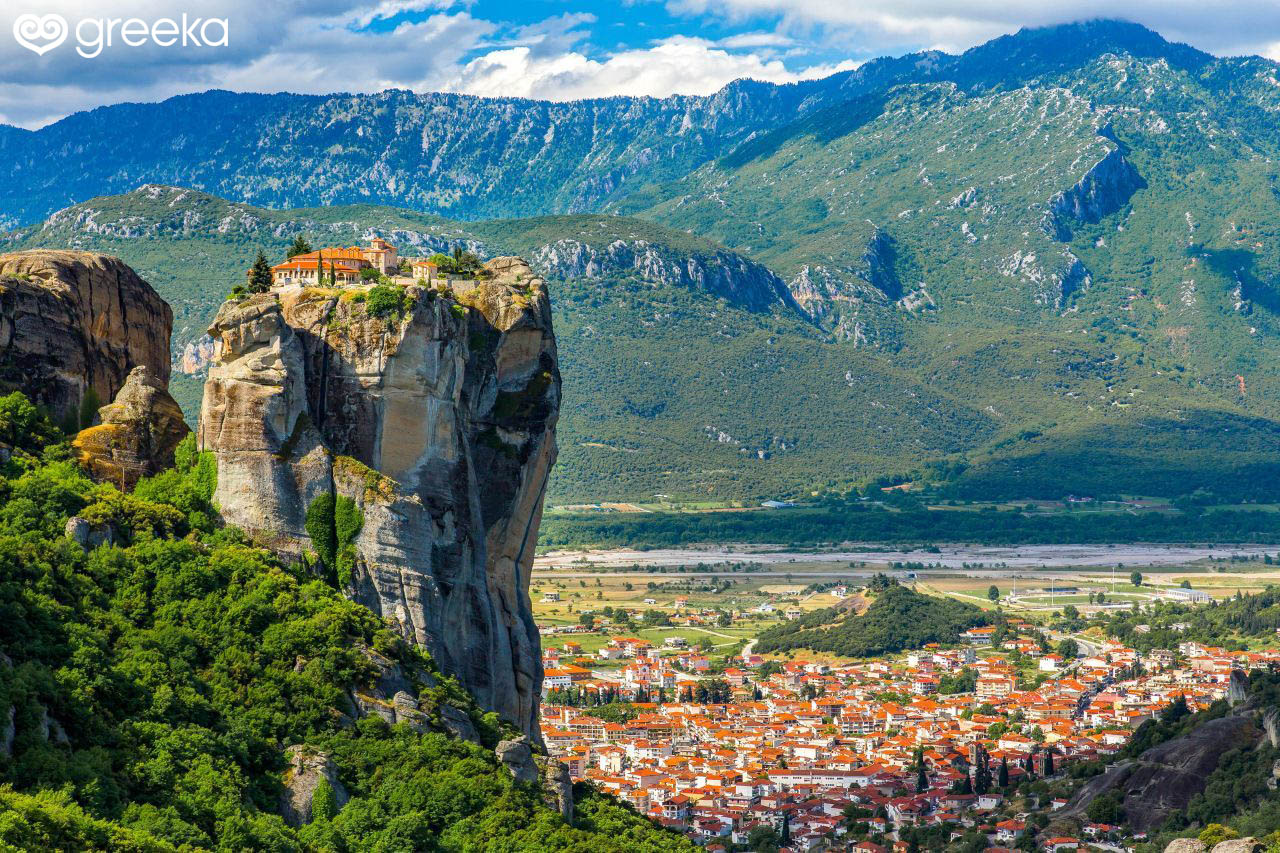What are the key elements in this picture? The image showcases the stunning landscape of Meteora in central Greece. Dominating the scene is a towering rock formation, upon which sits a monastery that appears almost suspended in the air. This beige rock formation is interspersed with patches of greenery, creating a compelling contrast. Below, the vibrant town is a mosaic of orange, white, and red-roofed buildings, nestled into the valley with a backdrop of farther-reaching dark green mountains lightly dusted in softer shades of green. Overhead, a bright blue sky filled with fluffy white clouds further adds to the serene and picturesque quality of the image. 